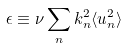Convert formula to latex. <formula><loc_0><loc_0><loc_500><loc_500>\epsilon \equiv \nu \sum _ { n } k _ { n } ^ { 2 } \langle u _ { n } ^ { 2 } \rangle</formula> 